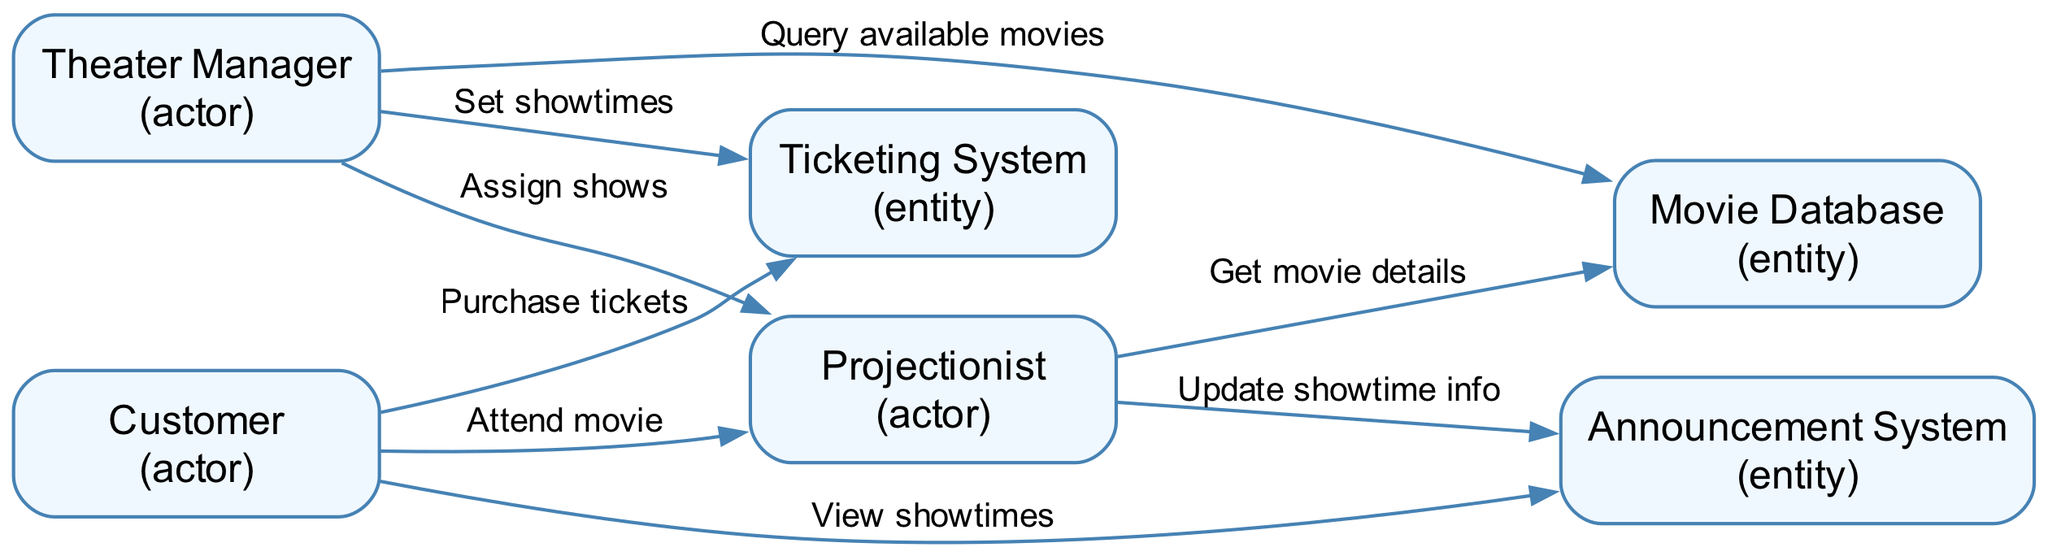What is the total number of entities in the diagram? There are six elements listed in the diagram: Movie Database, Ticketing System, Announcement System, and three actors: Theater Manager, Projectionist, and Customer. Entities include only Movie Database, Ticketing System, and Announcement System. Therefore, the total number of entities is three.
Answer: 3 Who interacts with the Ticketing System? The Ticketing System has two interactions in the diagram: one where the Theater Manager sets showtimes and another where the Customer purchases tickets.
Answer: Theater Manager and Customer What is the role of the Theater Manager in the workflow? The Theater Manager is responsible for scheduling movies and managing showtimes, by querying available movies from the Movie Database and setting showtimes in the Ticketing System.
Answer: Scheduling movies Which entity broadcasts showtime information? The Announcement System is responsible for broadcasting showtime information to customers inside the theater. This is indicated by the edge from the Projectionist to the Announcement System.
Answer: Announcement System How many edges are connected to the Projectionist? The Projectionist has three edges connected to it: one from the Theater Manager, one from the Movie Database, and one to the Announcement System. Thus, there are three edges connected to the Projectionist.
Answer: 3 What action does the Customer take towards the Announcement System? The Customer interacts with the Announcement System to view showtimes, as depicted by the edge connecting the Customer to the Announcement System. This action is specifically labeled in the diagram.
Answer: View showtimes What information is queried from the Movie Database? The Theater Manager queries available movies from the Movie Database to gather information required for scheduling. This action is explicitly mentioned in the sequence of interactions in the diagram.
Answer: Available movies Which element is responsible for setting showtimes? The Theater Manager is responsible for setting showtimes in the Ticketing System, as clearly indicated by the edge labeled "Set showtimes" in the diagram.
Answer: Theater Manager What is the sequence of actions starting from the Projectionist to the Announcement System? The sequence starts with the Projectionist getting movie details from the Movie Database, followed by updating showtime info in the Announcement System. These two interactions show a clear flow from one element to another.
Answer: Get movie details, Update showtime info 